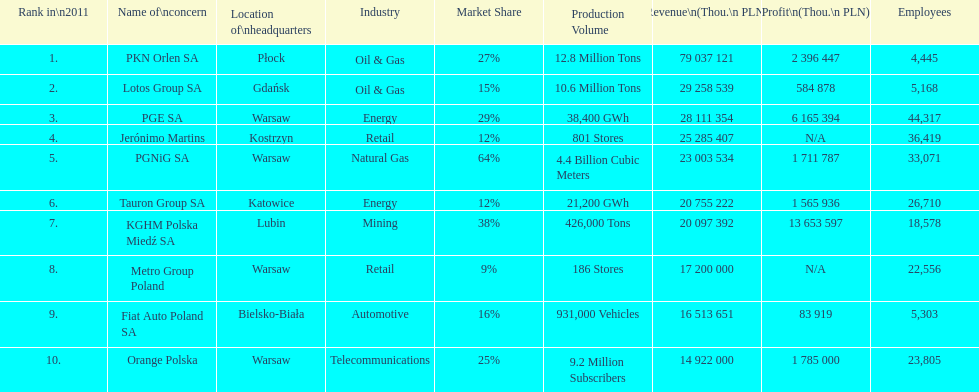What is the difference in employees for rank 1 and rank 3? 39,872 employees. 